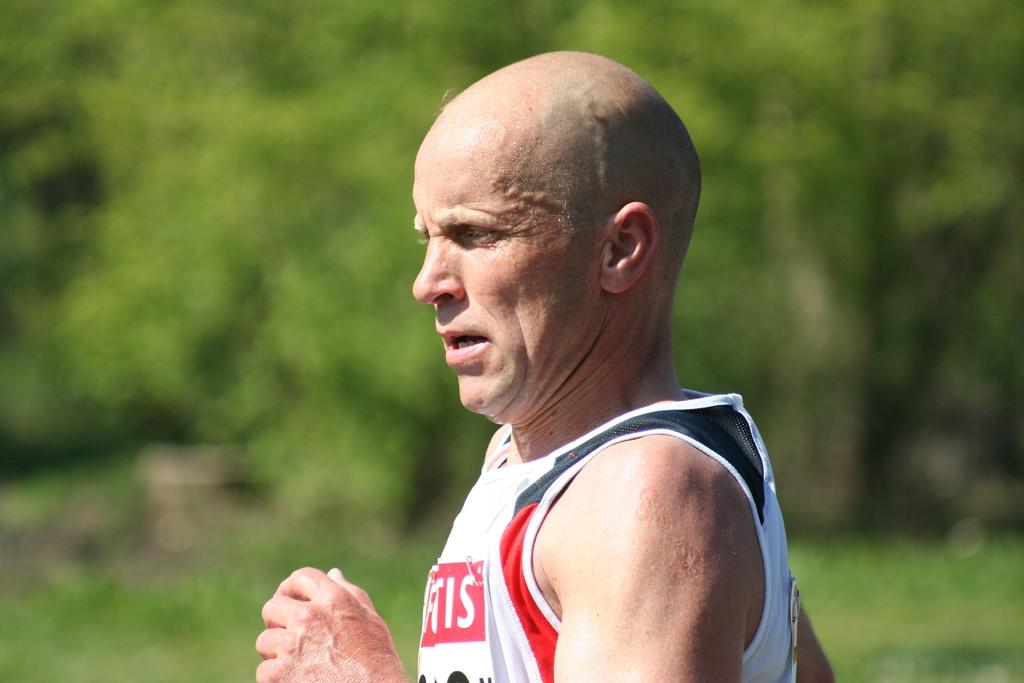<image>
Relay a brief, clear account of the picture shown. A man wearing a shirt that has the letters IS is running near some trees. 